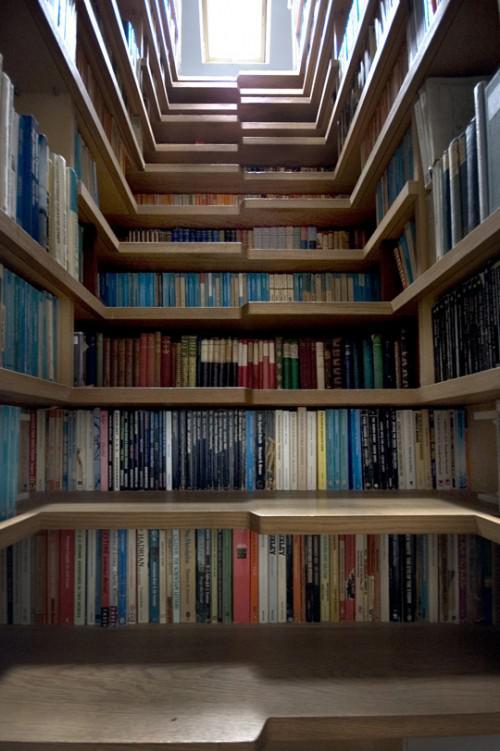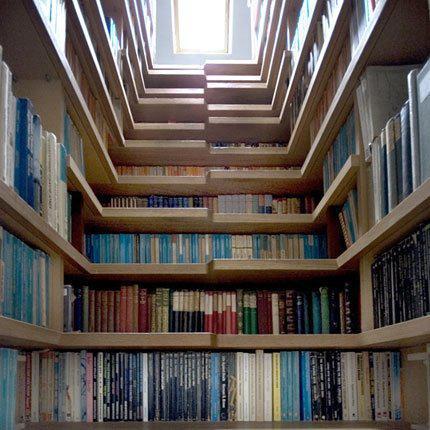The first image is the image on the left, the second image is the image on the right. Examine the images to the left and right. Is the description "One set of shelves has a built in window bench." accurate? Answer yes or no. No. 